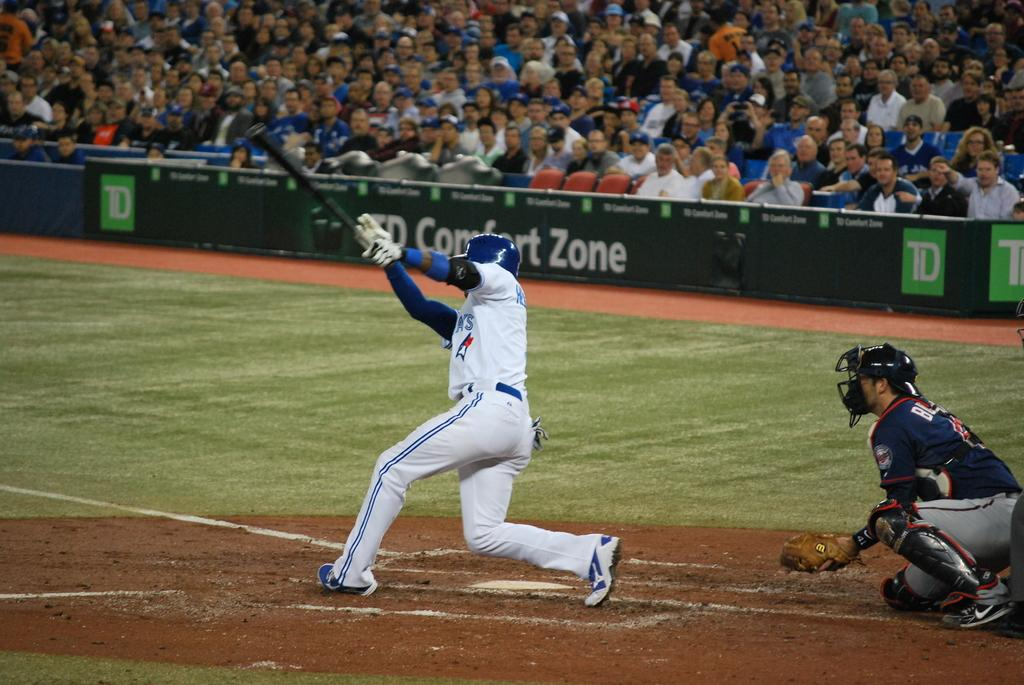<image>
Create a compact narrative representing the image presented. Catcher and batter playing on baseball field in front of tons of fans with TD Comfort Zone on the banner. 